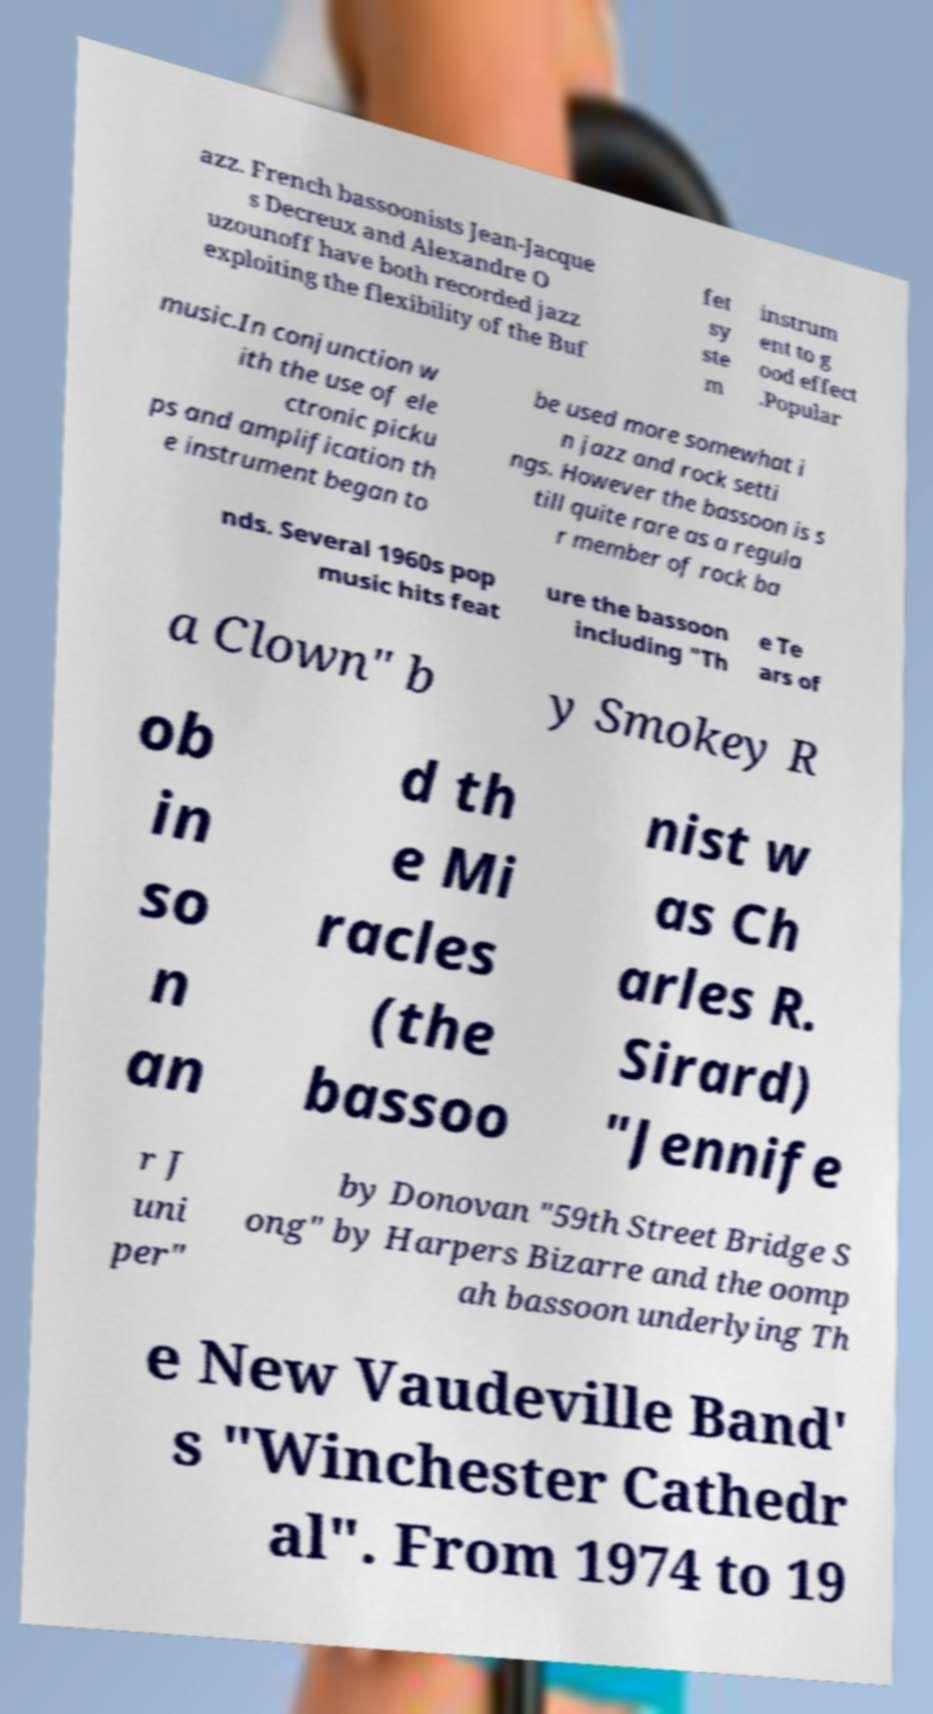Can you detail any specific events or albums where these bassoonists made significant contributions using their Buffet system instruments? Jean-Jacques Decreux and Alexandre Ouzounoff have both significantly utilized the Buffet system bassoons in their jazz performances. Decreux is known for his albums in the early 2000s where he blends classical and jazz styles. Ouzounoff has contributed to several notable jazz fusion projects throughout the 1990s, often collaborating with other prominent musicians to explore the rich tonal possibilities of the bassoon in this genre. 